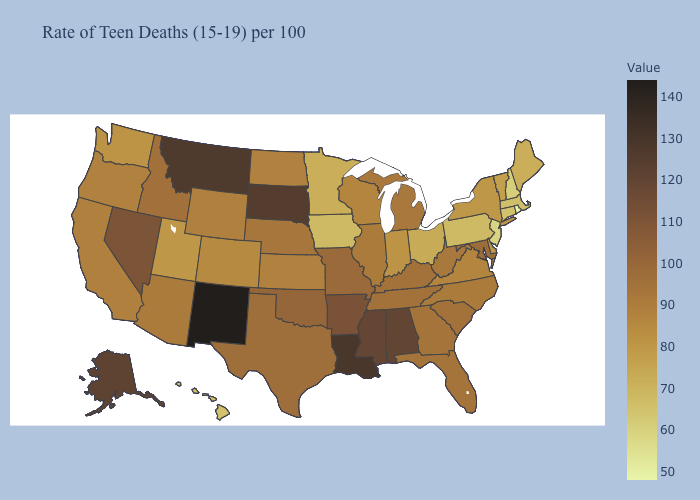Which states have the highest value in the USA?
Write a very short answer. New Mexico. Among the states that border Washington , does Oregon have the highest value?
Keep it brief. No. Does Texas have the lowest value in the South?
Give a very brief answer. No. Does the map have missing data?
Keep it brief. No. Does Indiana have a higher value than Missouri?
Quick response, please. No. Does Utah have the lowest value in the West?
Short answer required. No. Is the legend a continuous bar?
Answer briefly. Yes. Does New Mexico have the highest value in the USA?
Short answer required. Yes. 